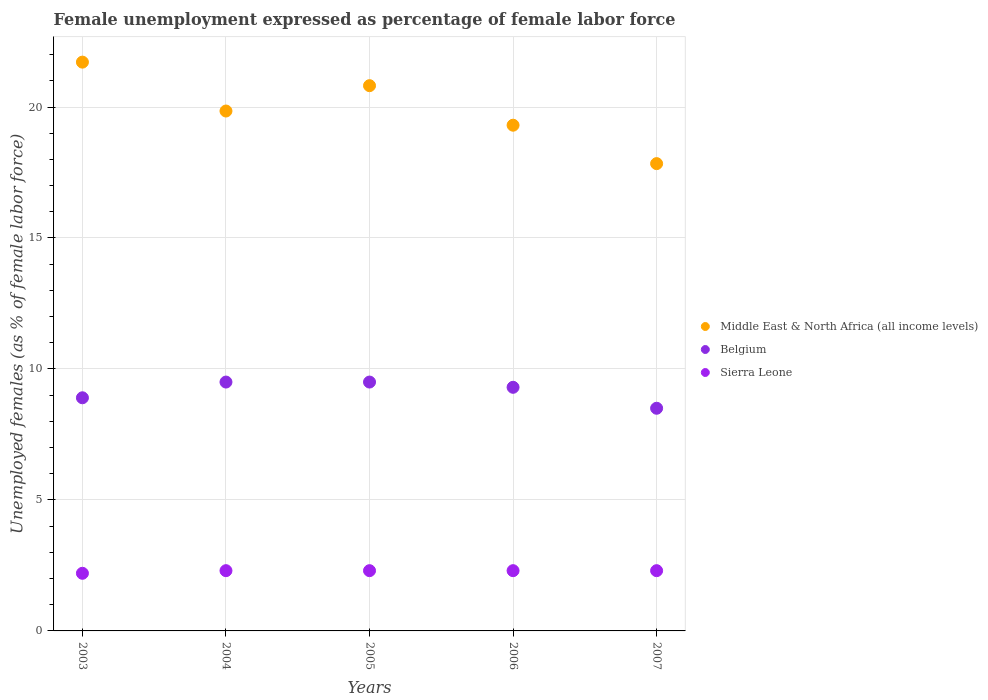Is the number of dotlines equal to the number of legend labels?
Ensure brevity in your answer.  Yes. What is the unemployment in females in in Sierra Leone in 2007?
Make the answer very short. 2.3. Across all years, what is the maximum unemployment in females in in Belgium?
Your answer should be compact. 9.5. Across all years, what is the minimum unemployment in females in in Middle East & North Africa (all income levels)?
Provide a short and direct response. 17.84. In which year was the unemployment in females in in Middle East & North Africa (all income levels) maximum?
Your answer should be very brief. 2003. What is the total unemployment in females in in Sierra Leone in the graph?
Your answer should be very brief. 11.4. What is the difference between the unemployment in females in in Belgium in 2003 and that in 2006?
Keep it short and to the point. -0.4. What is the difference between the unemployment in females in in Middle East & North Africa (all income levels) in 2004 and the unemployment in females in in Sierra Leone in 2007?
Make the answer very short. 17.55. What is the average unemployment in females in in Belgium per year?
Offer a terse response. 9.14. In the year 2006, what is the difference between the unemployment in females in in Middle East & North Africa (all income levels) and unemployment in females in in Belgium?
Offer a very short reply. 10.01. What is the ratio of the unemployment in females in in Belgium in 2003 to that in 2005?
Give a very brief answer. 0.94. What is the difference between the highest and the second highest unemployment in females in in Belgium?
Provide a succinct answer. 0. What is the difference between the highest and the lowest unemployment in females in in Sierra Leone?
Your answer should be compact. 0.1. Is the sum of the unemployment in females in in Belgium in 2003 and 2007 greater than the maximum unemployment in females in in Middle East & North Africa (all income levels) across all years?
Keep it short and to the point. No. Is it the case that in every year, the sum of the unemployment in females in in Sierra Leone and unemployment in females in in Belgium  is greater than the unemployment in females in in Middle East & North Africa (all income levels)?
Make the answer very short. No. Does the unemployment in females in in Middle East & North Africa (all income levels) monotonically increase over the years?
Provide a short and direct response. No. Is the unemployment in females in in Belgium strictly greater than the unemployment in females in in Middle East & North Africa (all income levels) over the years?
Provide a succinct answer. No. How many dotlines are there?
Make the answer very short. 3. Are the values on the major ticks of Y-axis written in scientific E-notation?
Make the answer very short. No. Does the graph contain grids?
Give a very brief answer. Yes. What is the title of the graph?
Make the answer very short. Female unemployment expressed as percentage of female labor force. Does "Yemen, Rep." appear as one of the legend labels in the graph?
Make the answer very short. No. What is the label or title of the X-axis?
Make the answer very short. Years. What is the label or title of the Y-axis?
Ensure brevity in your answer.  Unemployed females (as % of female labor force). What is the Unemployed females (as % of female labor force) of Middle East & North Africa (all income levels) in 2003?
Your answer should be compact. 21.71. What is the Unemployed females (as % of female labor force) of Belgium in 2003?
Your answer should be very brief. 8.9. What is the Unemployed females (as % of female labor force) of Sierra Leone in 2003?
Your answer should be compact. 2.2. What is the Unemployed females (as % of female labor force) in Middle East & North Africa (all income levels) in 2004?
Your answer should be compact. 19.85. What is the Unemployed females (as % of female labor force) in Belgium in 2004?
Provide a succinct answer. 9.5. What is the Unemployed females (as % of female labor force) in Sierra Leone in 2004?
Provide a short and direct response. 2.3. What is the Unemployed females (as % of female labor force) of Middle East & North Africa (all income levels) in 2005?
Provide a short and direct response. 20.81. What is the Unemployed females (as % of female labor force) in Belgium in 2005?
Your answer should be compact. 9.5. What is the Unemployed females (as % of female labor force) of Sierra Leone in 2005?
Keep it short and to the point. 2.3. What is the Unemployed females (as % of female labor force) in Middle East & North Africa (all income levels) in 2006?
Your response must be concise. 19.31. What is the Unemployed females (as % of female labor force) in Belgium in 2006?
Your response must be concise. 9.3. What is the Unemployed females (as % of female labor force) of Sierra Leone in 2006?
Provide a succinct answer. 2.3. What is the Unemployed females (as % of female labor force) in Middle East & North Africa (all income levels) in 2007?
Your answer should be compact. 17.84. What is the Unemployed females (as % of female labor force) in Belgium in 2007?
Provide a short and direct response. 8.5. What is the Unemployed females (as % of female labor force) of Sierra Leone in 2007?
Make the answer very short. 2.3. Across all years, what is the maximum Unemployed females (as % of female labor force) of Middle East & North Africa (all income levels)?
Your answer should be compact. 21.71. Across all years, what is the maximum Unemployed females (as % of female labor force) of Belgium?
Keep it short and to the point. 9.5. Across all years, what is the maximum Unemployed females (as % of female labor force) in Sierra Leone?
Ensure brevity in your answer.  2.3. Across all years, what is the minimum Unemployed females (as % of female labor force) of Middle East & North Africa (all income levels)?
Your answer should be very brief. 17.84. Across all years, what is the minimum Unemployed females (as % of female labor force) of Sierra Leone?
Provide a succinct answer. 2.2. What is the total Unemployed females (as % of female labor force) in Middle East & North Africa (all income levels) in the graph?
Make the answer very short. 99.52. What is the total Unemployed females (as % of female labor force) in Belgium in the graph?
Ensure brevity in your answer.  45.7. What is the total Unemployed females (as % of female labor force) of Sierra Leone in the graph?
Ensure brevity in your answer.  11.4. What is the difference between the Unemployed females (as % of female labor force) of Middle East & North Africa (all income levels) in 2003 and that in 2004?
Your answer should be compact. 1.87. What is the difference between the Unemployed females (as % of female labor force) in Belgium in 2003 and that in 2004?
Give a very brief answer. -0.6. What is the difference between the Unemployed females (as % of female labor force) in Middle East & North Africa (all income levels) in 2003 and that in 2005?
Keep it short and to the point. 0.9. What is the difference between the Unemployed females (as % of female labor force) in Sierra Leone in 2003 and that in 2005?
Give a very brief answer. -0.1. What is the difference between the Unemployed females (as % of female labor force) in Middle East & North Africa (all income levels) in 2003 and that in 2006?
Your answer should be compact. 2.41. What is the difference between the Unemployed females (as % of female labor force) in Belgium in 2003 and that in 2006?
Your answer should be very brief. -0.4. What is the difference between the Unemployed females (as % of female labor force) of Middle East & North Africa (all income levels) in 2003 and that in 2007?
Ensure brevity in your answer.  3.87. What is the difference between the Unemployed females (as % of female labor force) in Belgium in 2003 and that in 2007?
Provide a short and direct response. 0.4. What is the difference between the Unemployed females (as % of female labor force) in Sierra Leone in 2003 and that in 2007?
Your answer should be very brief. -0.1. What is the difference between the Unemployed females (as % of female labor force) in Middle East & North Africa (all income levels) in 2004 and that in 2005?
Offer a terse response. -0.97. What is the difference between the Unemployed females (as % of female labor force) of Middle East & North Africa (all income levels) in 2004 and that in 2006?
Your answer should be compact. 0.54. What is the difference between the Unemployed females (as % of female labor force) in Belgium in 2004 and that in 2006?
Offer a very short reply. 0.2. What is the difference between the Unemployed females (as % of female labor force) of Middle East & North Africa (all income levels) in 2004 and that in 2007?
Your answer should be very brief. 2.01. What is the difference between the Unemployed females (as % of female labor force) in Middle East & North Africa (all income levels) in 2005 and that in 2006?
Offer a terse response. 1.51. What is the difference between the Unemployed females (as % of female labor force) in Sierra Leone in 2005 and that in 2006?
Give a very brief answer. 0. What is the difference between the Unemployed females (as % of female labor force) in Middle East & North Africa (all income levels) in 2005 and that in 2007?
Offer a terse response. 2.98. What is the difference between the Unemployed females (as % of female labor force) in Middle East & North Africa (all income levels) in 2006 and that in 2007?
Your answer should be compact. 1.47. What is the difference between the Unemployed females (as % of female labor force) in Belgium in 2006 and that in 2007?
Your answer should be compact. 0.8. What is the difference between the Unemployed females (as % of female labor force) in Sierra Leone in 2006 and that in 2007?
Your answer should be compact. 0. What is the difference between the Unemployed females (as % of female labor force) of Middle East & North Africa (all income levels) in 2003 and the Unemployed females (as % of female labor force) of Belgium in 2004?
Give a very brief answer. 12.21. What is the difference between the Unemployed females (as % of female labor force) in Middle East & North Africa (all income levels) in 2003 and the Unemployed females (as % of female labor force) in Sierra Leone in 2004?
Make the answer very short. 19.41. What is the difference between the Unemployed females (as % of female labor force) of Belgium in 2003 and the Unemployed females (as % of female labor force) of Sierra Leone in 2004?
Your answer should be very brief. 6.6. What is the difference between the Unemployed females (as % of female labor force) in Middle East & North Africa (all income levels) in 2003 and the Unemployed females (as % of female labor force) in Belgium in 2005?
Provide a short and direct response. 12.21. What is the difference between the Unemployed females (as % of female labor force) of Middle East & North Africa (all income levels) in 2003 and the Unemployed females (as % of female labor force) of Sierra Leone in 2005?
Provide a succinct answer. 19.41. What is the difference between the Unemployed females (as % of female labor force) of Middle East & North Africa (all income levels) in 2003 and the Unemployed females (as % of female labor force) of Belgium in 2006?
Give a very brief answer. 12.41. What is the difference between the Unemployed females (as % of female labor force) in Middle East & North Africa (all income levels) in 2003 and the Unemployed females (as % of female labor force) in Sierra Leone in 2006?
Offer a very short reply. 19.41. What is the difference between the Unemployed females (as % of female labor force) of Middle East & North Africa (all income levels) in 2003 and the Unemployed females (as % of female labor force) of Belgium in 2007?
Provide a short and direct response. 13.21. What is the difference between the Unemployed females (as % of female labor force) of Middle East & North Africa (all income levels) in 2003 and the Unemployed females (as % of female labor force) of Sierra Leone in 2007?
Make the answer very short. 19.41. What is the difference between the Unemployed females (as % of female labor force) of Middle East & North Africa (all income levels) in 2004 and the Unemployed females (as % of female labor force) of Belgium in 2005?
Offer a terse response. 10.35. What is the difference between the Unemployed females (as % of female labor force) in Middle East & North Africa (all income levels) in 2004 and the Unemployed females (as % of female labor force) in Sierra Leone in 2005?
Provide a succinct answer. 17.55. What is the difference between the Unemployed females (as % of female labor force) of Middle East & North Africa (all income levels) in 2004 and the Unemployed females (as % of female labor force) of Belgium in 2006?
Make the answer very short. 10.55. What is the difference between the Unemployed females (as % of female labor force) of Middle East & North Africa (all income levels) in 2004 and the Unemployed females (as % of female labor force) of Sierra Leone in 2006?
Your response must be concise. 17.55. What is the difference between the Unemployed females (as % of female labor force) of Middle East & North Africa (all income levels) in 2004 and the Unemployed females (as % of female labor force) of Belgium in 2007?
Make the answer very short. 11.35. What is the difference between the Unemployed females (as % of female labor force) of Middle East & North Africa (all income levels) in 2004 and the Unemployed females (as % of female labor force) of Sierra Leone in 2007?
Keep it short and to the point. 17.55. What is the difference between the Unemployed females (as % of female labor force) in Middle East & North Africa (all income levels) in 2005 and the Unemployed females (as % of female labor force) in Belgium in 2006?
Your answer should be very brief. 11.51. What is the difference between the Unemployed females (as % of female labor force) of Middle East & North Africa (all income levels) in 2005 and the Unemployed females (as % of female labor force) of Sierra Leone in 2006?
Provide a succinct answer. 18.51. What is the difference between the Unemployed females (as % of female labor force) of Belgium in 2005 and the Unemployed females (as % of female labor force) of Sierra Leone in 2006?
Your answer should be compact. 7.2. What is the difference between the Unemployed females (as % of female labor force) of Middle East & North Africa (all income levels) in 2005 and the Unemployed females (as % of female labor force) of Belgium in 2007?
Offer a very short reply. 12.31. What is the difference between the Unemployed females (as % of female labor force) of Middle East & North Africa (all income levels) in 2005 and the Unemployed females (as % of female labor force) of Sierra Leone in 2007?
Ensure brevity in your answer.  18.51. What is the difference between the Unemployed females (as % of female labor force) of Belgium in 2005 and the Unemployed females (as % of female labor force) of Sierra Leone in 2007?
Provide a short and direct response. 7.2. What is the difference between the Unemployed females (as % of female labor force) of Middle East & North Africa (all income levels) in 2006 and the Unemployed females (as % of female labor force) of Belgium in 2007?
Provide a short and direct response. 10.81. What is the difference between the Unemployed females (as % of female labor force) of Middle East & North Africa (all income levels) in 2006 and the Unemployed females (as % of female labor force) of Sierra Leone in 2007?
Your answer should be very brief. 17.01. What is the difference between the Unemployed females (as % of female labor force) in Belgium in 2006 and the Unemployed females (as % of female labor force) in Sierra Leone in 2007?
Your answer should be compact. 7. What is the average Unemployed females (as % of female labor force) in Middle East & North Africa (all income levels) per year?
Ensure brevity in your answer.  19.9. What is the average Unemployed females (as % of female labor force) in Belgium per year?
Your answer should be very brief. 9.14. What is the average Unemployed females (as % of female labor force) in Sierra Leone per year?
Provide a short and direct response. 2.28. In the year 2003, what is the difference between the Unemployed females (as % of female labor force) in Middle East & North Africa (all income levels) and Unemployed females (as % of female labor force) in Belgium?
Ensure brevity in your answer.  12.81. In the year 2003, what is the difference between the Unemployed females (as % of female labor force) in Middle East & North Africa (all income levels) and Unemployed females (as % of female labor force) in Sierra Leone?
Your answer should be compact. 19.51. In the year 2003, what is the difference between the Unemployed females (as % of female labor force) in Belgium and Unemployed females (as % of female labor force) in Sierra Leone?
Make the answer very short. 6.7. In the year 2004, what is the difference between the Unemployed females (as % of female labor force) in Middle East & North Africa (all income levels) and Unemployed females (as % of female labor force) in Belgium?
Give a very brief answer. 10.35. In the year 2004, what is the difference between the Unemployed females (as % of female labor force) of Middle East & North Africa (all income levels) and Unemployed females (as % of female labor force) of Sierra Leone?
Your response must be concise. 17.55. In the year 2004, what is the difference between the Unemployed females (as % of female labor force) in Belgium and Unemployed females (as % of female labor force) in Sierra Leone?
Your response must be concise. 7.2. In the year 2005, what is the difference between the Unemployed females (as % of female labor force) of Middle East & North Africa (all income levels) and Unemployed females (as % of female labor force) of Belgium?
Ensure brevity in your answer.  11.31. In the year 2005, what is the difference between the Unemployed females (as % of female labor force) in Middle East & North Africa (all income levels) and Unemployed females (as % of female labor force) in Sierra Leone?
Keep it short and to the point. 18.51. In the year 2005, what is the difference between the Unemployed females (as % of female labor force) of Belgium and Unemployed females (as % of female labor force) of Sierra Leone?
Offer a very short reply. 7.2. In the year 2006, what is the difference between the Unemployed females (as % of female labor force) of Middle East & North Africa (all income levels) and Unemployed females (as % of female labor force) of Belgium?
Your response must be concise. 10.01. In the year 2006, what is the difference between the Unemployed females (as % of female labor force) in Middle East & North Africa (all income levels) and Unemployed females (as % of female labor force) in Sierra Leone?
Provide a short and direct response. 17.01. In the year 2006, what is the difference between the Unemployed females (as % of female labor force) of Belgium and Unemployed females (as % of female labor force) of Sierra Leone?
Make the answer very short. 7. In the year 2007, what is the difference between the Unemployed females (as % of female labor force) in Middle East & North Africa (all income levels) and Unemployed females (as % of female labor force) in Belgium?
Your answer should be very brief. 9.34. In the year 2007, what is the difference between the Unemployed females (as % of female labor force) of Middle East & North Africa (all income levels) and Unemployed females (as % of female labor force) of Sierra Leone?
Give a very brief answer. 15.54. In the year 2007, what is the difference between the Unemployed females (as % of female labor force) in Belgium and Unemployed females (as % of female labor force) in Sierra Leone?
Give a very brief answer. 6.2. What is the ratio of the Unemployed females (as % of female labor force) in Middle East & North Africa (all income levels) in 2003 to that in 2004?
Offer a very short reply. 1.09. What is the ratio of the Unemployed females (as % of female labor force) of Belgium in 2003 to that in 2004?
Ensure brevity in your answer.  0.94. What is the ratio of the Unemployed females (as % of female labor force) in Sierra Leone in 2003 to that in 2004?
Offer a terse response. 0.96. What is the ratio of the Unemployed females (as % of female labor force) of Middle East & North Africa (all income levels) in 2003 to that in 2005?
Provide a short and direct response. 1.04. What is the ratio of the Unemployed females (as % of female labor force) of Belgium in 2003 to that in 2005?
Your answer should be very brief. 0.94. What is the ratio of the Unemployed females (as % of female labor force) in Sierra Leone in 2003 to that in 2005?
Provide a succinct answer. 0.96. What is the ratio of the Unemployed females (as % of female labor force) in Middle East & North Africa (all income levels) in 2003 to that in 2006?
Your response must be concise. 1.12. What is the ratio of the Unemployed females (as % of female labor force) of Belgium in 2003 to that in 2006?
Offer a very short reply. 0.96. What is the ratio of the Unemployed females (as % of female labor force) in Sierra Leone in 2003 to that in 2006?
Offer a very short reply. 0.96. What is the ratio of the Unemployed females (as % of female labor force) of Middle East & North Africa (all income levels) in 2003 to that in 2007?
Your answer should be very brief. 1.22. What is the ratio of the Unemployed females (as % of female labor force) of Belgium in 2003 to that in 2007?
Your answer should be compact. 1.05. What is the ratio of the Unemployed females (as % of female labor force) of Sierra Leone in 2003 to that in 2007?
Your answer should be very brief. 0.96. What is the ratio of the Unemployed females (as % of female labor force) of Middle East & North Africa (all income levels) in 2004 to that in 2005?
Your answer should be compact. 0.95. What is the ratio of the Unemployed females (as % of female labor force) of Sierra Leone in 2004 to that in 2005?
Give a very brief answer. 1. What is the ratio of the Unemployed females (as % of female labor force) of Middle East & North Africa (all income levels) in 2004 to that in 2006?
Give a very brief answer. 1.03. What is the ratio of the Unemployed females (as % of female labor force) of Belgium in 2004 to that in 2006?
Your answer should be very brief. 1.02. What is the ratio of the Unemployed females (as % of female labor force) in Middle East & North Africa (all income levels) in 2004 to that in 2007?
Give a very brief answer. 1.11. What is the ratio of the Unemployed females (as % of female labor force) of Belgium in 2004 to that in 2007?
Offer a terse response. 1.12. What is the ratio of the Unemployed females (as % of female labor force) in Sierra Leone in 2004 to that in 2007?
Your answer should be compact. 1. What is the ratio of the Unemployed females (as % of female labor force) in Middle East & North Africa (all income levels) in 2005 to that in 2006?
Your response must be concise. 1.08. What is the ratio of the Unemployed females (as % of female labor force) of Belgium in 2005 to that in 2006?
Your response must be concise. 1.02. What is the ratio of the Unemployed females (as % of female labor force) in Middle East & North Africa (all income levels) in 2005 to that in 2007?
Make the answer very short. 1.17. What is the ratio of the Unemployed females (as % of female labor force) in Belgium in 2005 to that in 2007?
Your answer should be compact. 1.12. What is the ratio of the Unemployed females (as % of female labor force) of Sierra Leone in 2005 to that in 2007?
Offer a very short reply. 1. What is the ratio of the Unemployed females (as % of female labor force) of Middle East & North Africa (all income levels) in 2006 to that in 2007?
Make the answer very short. 1.08. What is the ratio of the Unemployed females (as % of female labor force) of Belgium in 2006 to that in 2007?
Provide a succinct answer. 1.09. What is the difference between the highest and the second highest Unemployed females (as % of female labor force) of Middle East & North Africa (all income levels)?
Make the answer very short. 0.9. What is the difference between the highest and the second highest Unemployed females (as % of female labor force) of Belgium?
Ensure brevity in your answer.  0. What is the difference between the highest and the lowest Unemployed females (as % of female labor force) of Middle East & North Africa (all income levels)?
Offer a terse response. 3.87. What is the difference between the highest and the lowest Unemployed females (as % of female labor force) in Belgium?
Provide a short and direct response. 1. 